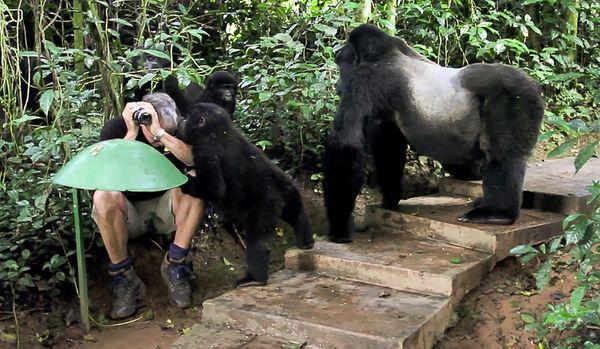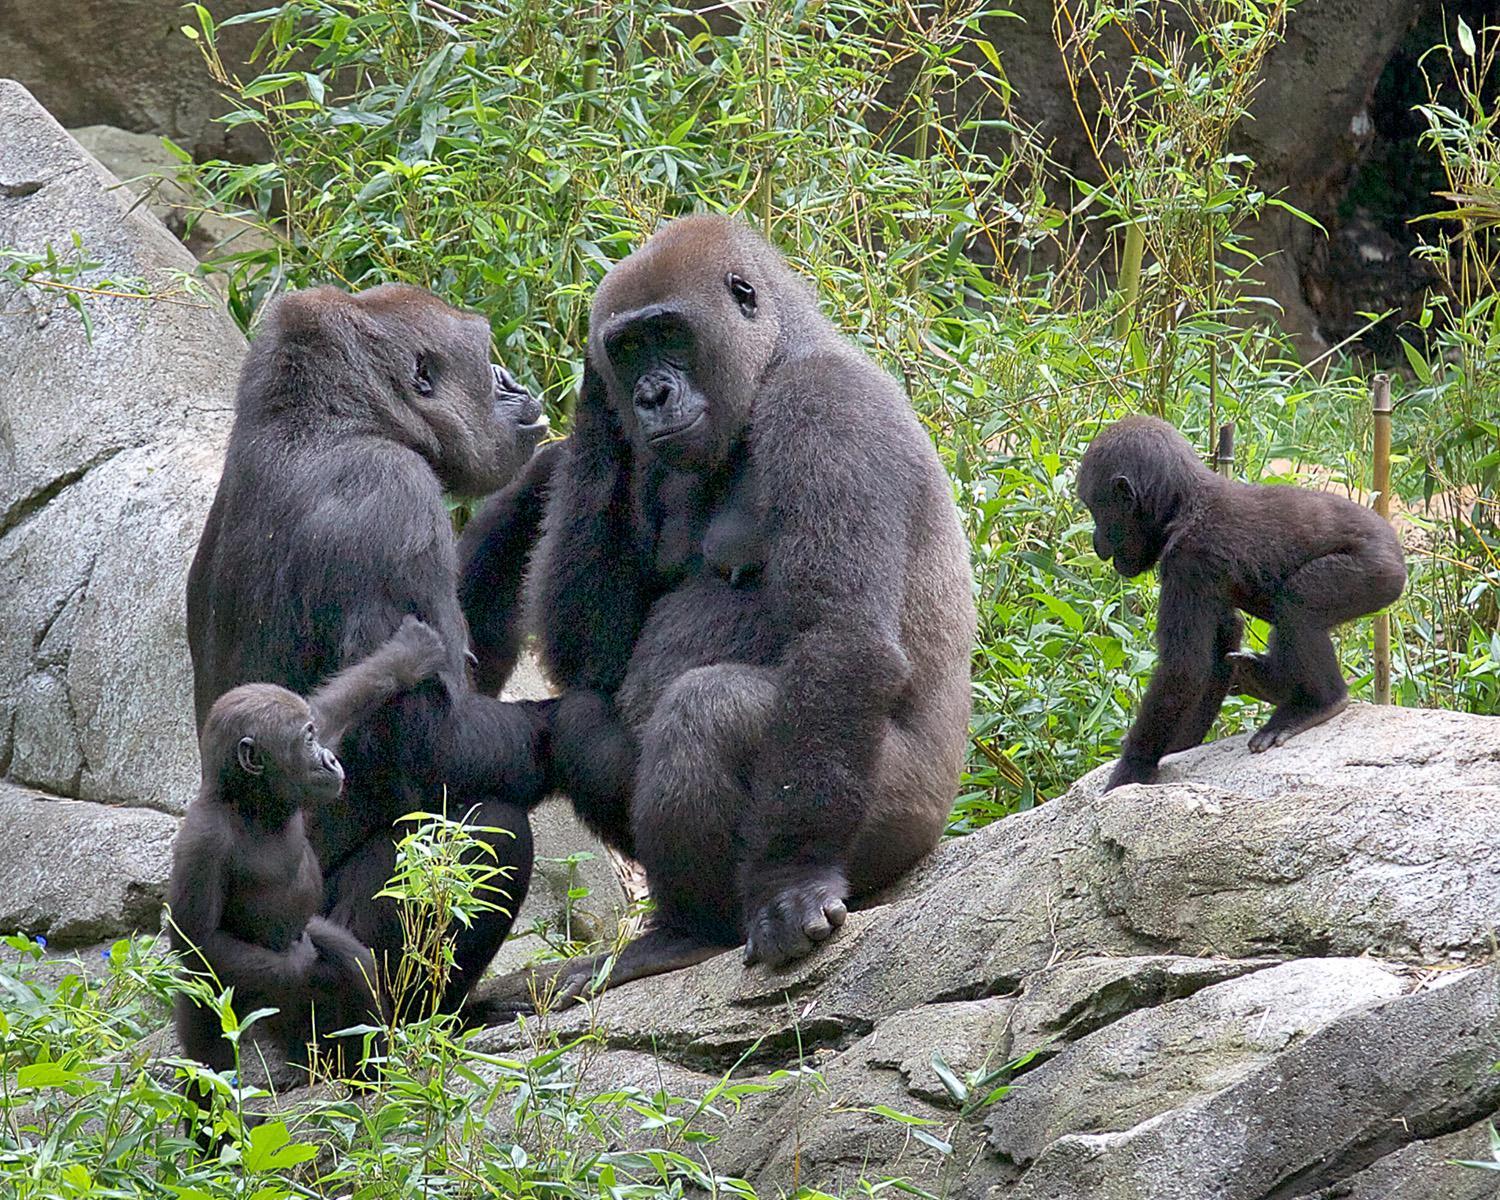The first image is the image on the left, the second image is the image on the right. Analyze the images presented: Is the assertion "The left image contains a human interacting with a gorilla." valid? Answer yes or no. Yes. 